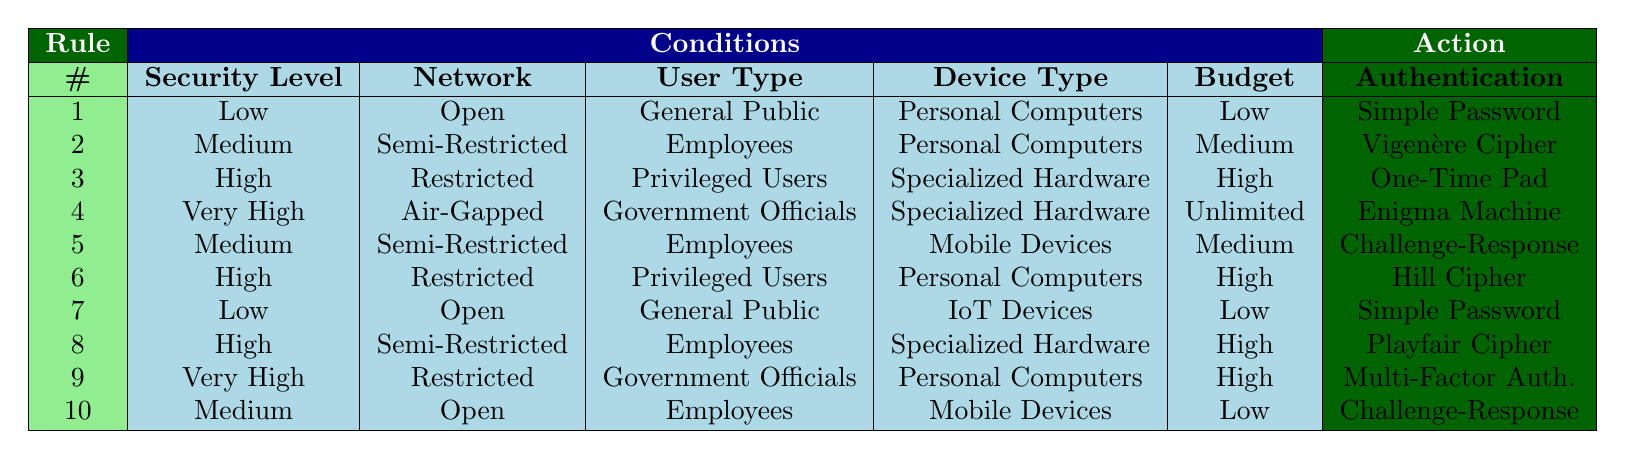What authentication mechanism is recommended for a high security level in a restricted network for privileged users using specialized hardware with a high budget? From the table, rule 3 specifies that when the conditions are High security level, Restricted network, Privileged Users, Specialized Hardware, and High budget, the recommended authentication mechanism is One-Time Pad.
Answer: One-Time Pad Is Multi-Factor Authentication suggested for government officials in air-gapped settings with very high security requirements? The table shows that for Very High security level, Air-Gapped network, Government Officials, Specialized Hardware, and Unlimited budget (rule 4), the recommended mechanism is the Enigma Machine, not Multi-Factor Authentication. Therefore, the suggestion for Multi-Factor Authentication is incorrect.
Answer: No What is the authentication mechanism for employees using personal computers in a semi-restricted environment with medium budget? Referring to rule 2 in the table, it states that for the conditions of Medium security level, Semi-Restricted network, Employees, Personal Computers, and Medium budget, the action is to use the Vigenère Cipher.
Answer: Vigenère Cipher How many authentication mechanisms are provided for low security environments? The table lists two rules that correspond to Low security environments: rule 1 for Open network, General Public, Personal Computers, and Low budget (resulting in Simple Password) and rule 7 for Open network, General Public, IoT Devices, and Low budget (also resulting in Simple Password). Thus, there is only one unique mechanism recommended here.
Answer: 1 In a semi-restricted environment with a high budget, what is the recommended authentication mechanism for privileged users using specialized hardware? By inspecting rule 8, which has the conditions of High security, Semi-Restricted network, Employees, Specialized Hardware, and High budget, we find that the recommended mechanism is the Playfair Cipher. This rule specifically addresses the conditions stated.
Answer: Playfair Cipher What is the authentication mechanism if employees on mobile devices in an open environment face budget constraints categorized as low? Looking at rule 10, we see that for the conditions of Medium security level, Open network, Employees, Mobile Devices, and Low budget, the action taken is Challenge-Response. Therefore, this mechanism is recommended under those conditions.
Answer: Challenge-Response For privileged users in restricted networks requiring high security, which authentication mechanism is utilized when the budget is high and they are using personal computers? The table's rule 6 details that for High security level, Restricted network, Privileged Users, Personal Computers, and High budget, the suggested authentication mechanism is Hill Cipher. This provides a clear direction for the given conditions.
Answer: Hill Cipher 